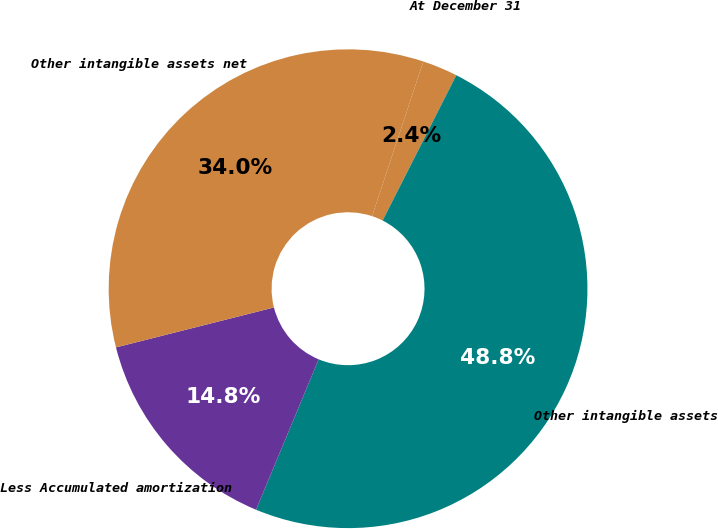Convert chart. <chart><loc_0><loc_0><loc_500><loc_500><pie_chart><fcel>At December 31<fcel>Other intangible assets<fcel>Less Accumulated amortization<fcel>Other intangible assets net<nl><fcel>2.38%<fcel>48.81%<fcel>14.78%<fcel>34.03%<nl></chart> 